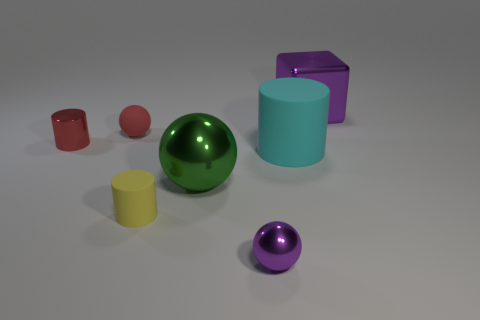How are the objects arranged in relation to each other? The objects are arranged haphazardly across the surface with varying distances between them, not following any discernible pattern.  Is there a feeling or theme that this arrangement might suggest? The scattered arrangement of objects with different shapes and colors could suggest themes of diversity or randomness, perhaps mimicking the unpredictability of elements in life. 